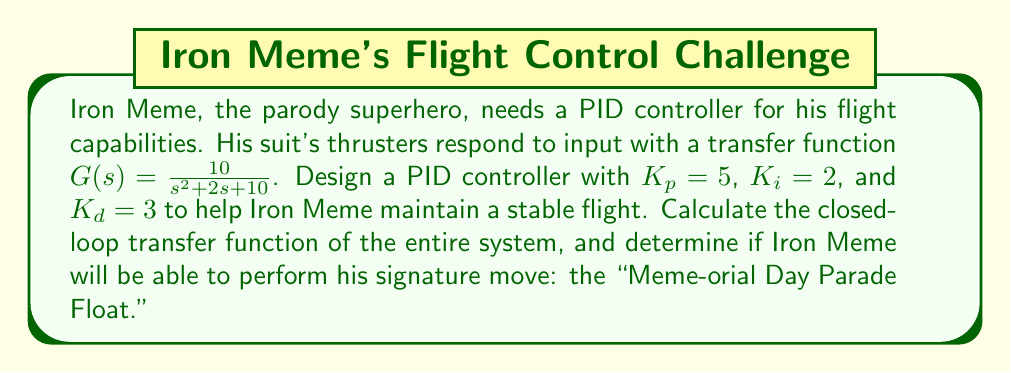What is the answer to this math problem? Let's approach this step-by-step:

1) The PID controller transfer function is given by:
   $$C(s) = K_p + \frac{K_i}{s} + K_d s$$

2) Substituting the given values:
   $$C(s) = 5 + \frac{2}{s} + 3s$$

3) The plant transfer function is:
   $$G(s) = \frac{10}{s^2 + 2s + 10}$$

4) The closed-loop transfer function is given by:
   $$T(s) = \frac{C(s)G(s)}{1 + C(s)G(s)}$$

5) Let's substitute C(s) and G(s):
   $$T(s) = \frac{(5 + \frac{2}{s} + 3s)(\frac{10}{s^2 + 2s + 10})}{1 + (5 + \frac{2}{s} + 3s)(\frac{10}{s^2 + 2s + 10})}$$

6) Simplify the numerator:
   $$T(s) = \frac{10(5s + 2 + 3s^2)}{s(s^2 + 2s + 10) + 10(5s + 2 + 3s^2)}$$

7) Expand the denominator:
   $$T(s) = \frac{10(3s^2 + 5s + 2)}{s^3 + 2s^2 + 10s + 30s^3 + 50s^2 + 20s}$$

8) Combine like terms:
   $$T(s) = \frac{10(3s^2 + 5s + 2)}{31s^3 + 52s^2 + 30s}$$

9) To determine if Iron Meme can perform his "Meme-orial Day Parade Float," we need to check the stability of the system. A quick way to do this is to check if all coefficients in the denominator are positive and non-zero, which they are in this case.

Therefore, the system is stable, and Iron Meme should be able to maintain controlled flight and perform his signature move!
Answer: The closed-loop transfer function is:
$$T(s) = \frac{10(3s^2 + 5s + 2)}{31s^3 + 52s^2 + 30s}$$
The system is stable, so Iron Meme can perform his "Meme-orial Day Parade Float." 